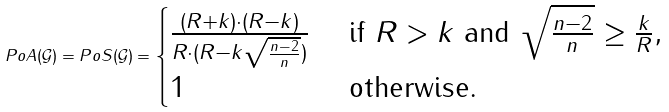Convert formula to latex. <formula><loc_0><loc_0><loc_500><loc_500>P o A ( \mathcal { G } ) = P o S ( \mathcal { G } ) = \begin{cases} \frac { ( R + k ) \cdot ( R - k ) } { R \cdot ( R - k \sqrt { \frac { n - 2 } { n } } ) } & \text { if } R > k \text { and } \sqrt { \frac { n - 2 } { n } } \geq \frac { k } { R } , \\ 1 & \text { otherwise.} \end{cases}</formula> 